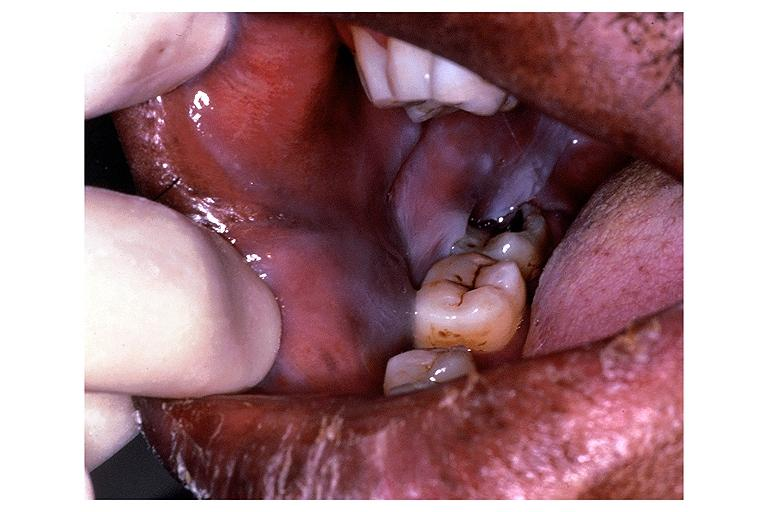does odontoid process subluxation with narrowing of foramen magnum show leukoedema?
Answer the question using a single word or phrase. No 